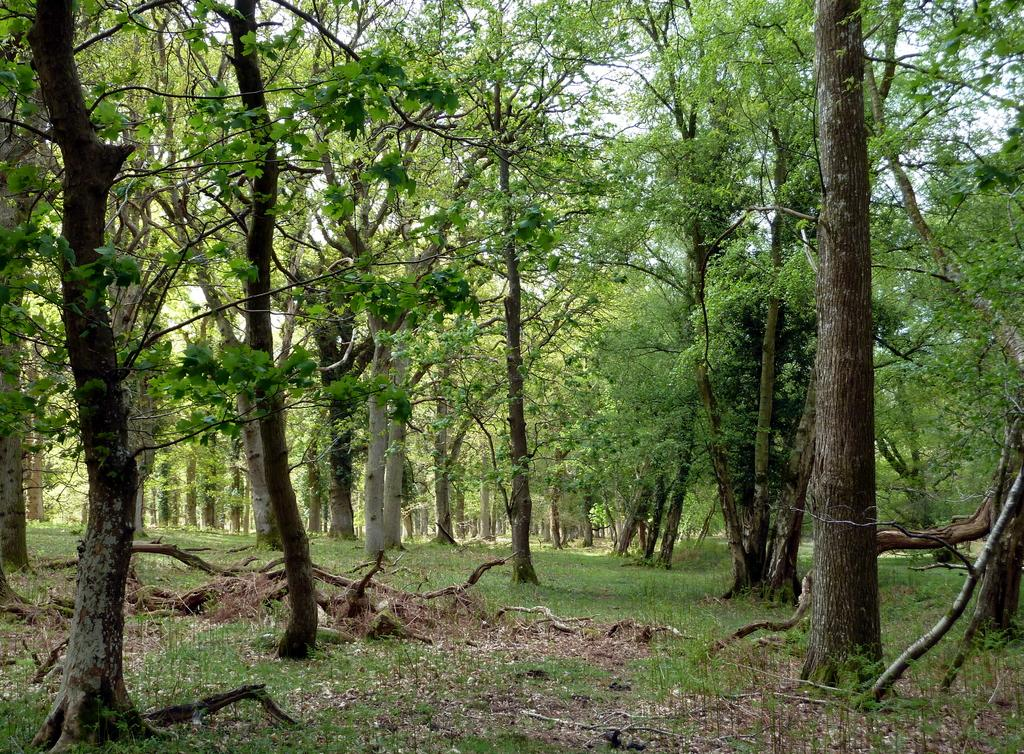What type of vegetation is present in the image? There are many trees in the image. What is the ground like where the trees are located? The trees are on a grassy land. What part of the natural environment is visible in the image? The sky is visible in the image. What color is the sky in the image? The sky is white in color. Where can the shelf be found in the image? There is no shelf present in the image. How does the grip of the trees affect the image? There is no mention of a grip or any interaction with the trees in the image. 